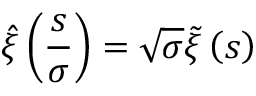<formula> <loc_0><loc_0><loc_500><loc_500>\hat { \xi } \left ( \frac { s } { \sigma } \right ) = \sqrt { \sigma } \tilde { \xi } \left ( s \right )</formula> 